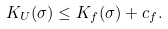<formula> <loc_0><loc_0><loc_500><loc_500>K _ { U } ( \sigma ) \leq K _ { f } ( \sigma ) + c _ { f } .</formula> 